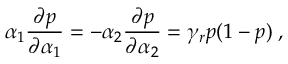<formula> <loc_0><loc_0><loc_500><loc_500>\alpha _ { 1 } \frac { \partial p } { \partial \alpha _ { 1 } } = - \alpha _ { 2 } \frac { \partial p } { \partial \alpha _ { 2 } } = \gamma _ { r } p ( 1 - p ) \, ,</formula> 